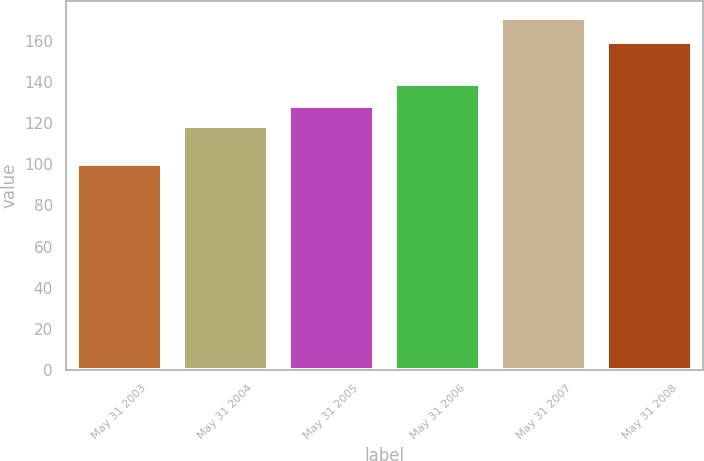<chart> <loc_0><loc_0><loc_500><loc_500><bar_chart><fcel>May 31 2003<fcel>May 31 2004<fcel>May 31 2005<fcel>May 31 2006<fcel>May 31 2007<fcel>May 31 2008<nl><fcel>100<fcel>118.33<fcel>128.07<fcel>139.14<fcel>170.85<fcel>159.41<nl></chart> 